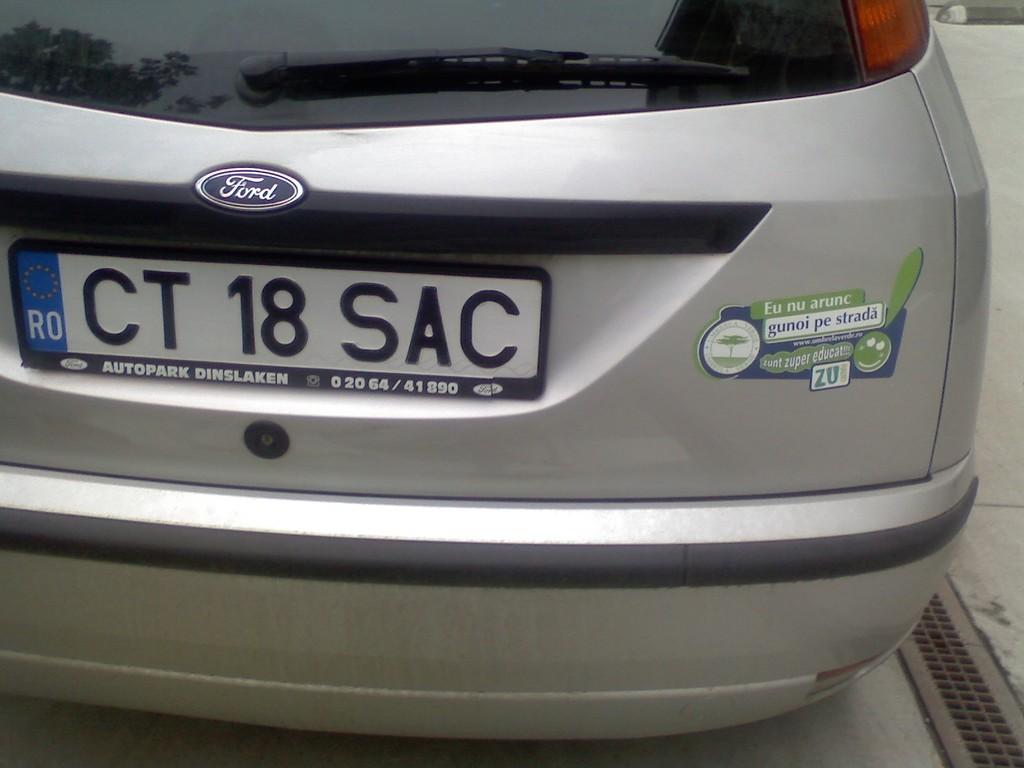What is the license plate number of this vehicle?
Make the answer very short. Ct 18 sac. What is the vehicle's brand?
Your answer should be very brief. Ford. 